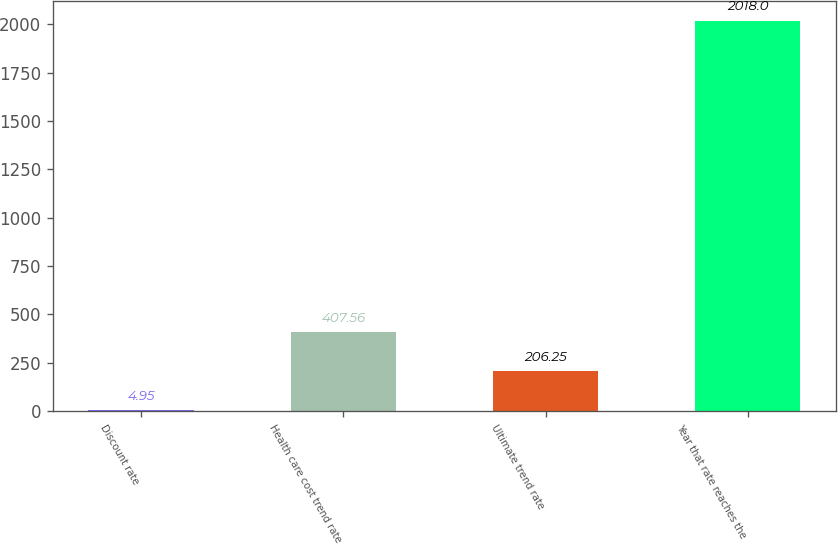Convert chart. <chart><loc_0><loc_0><loc_500><loc_500><bar_chart><fcel>Discount rate<fcel>Health care cost trend rate<fcel>Ultimate trend rate<fcel>Year that rate reaches the<nl><fcel>4.95<fcel>407.56<fcel>206.25<fcel>2018<nl></chart> 